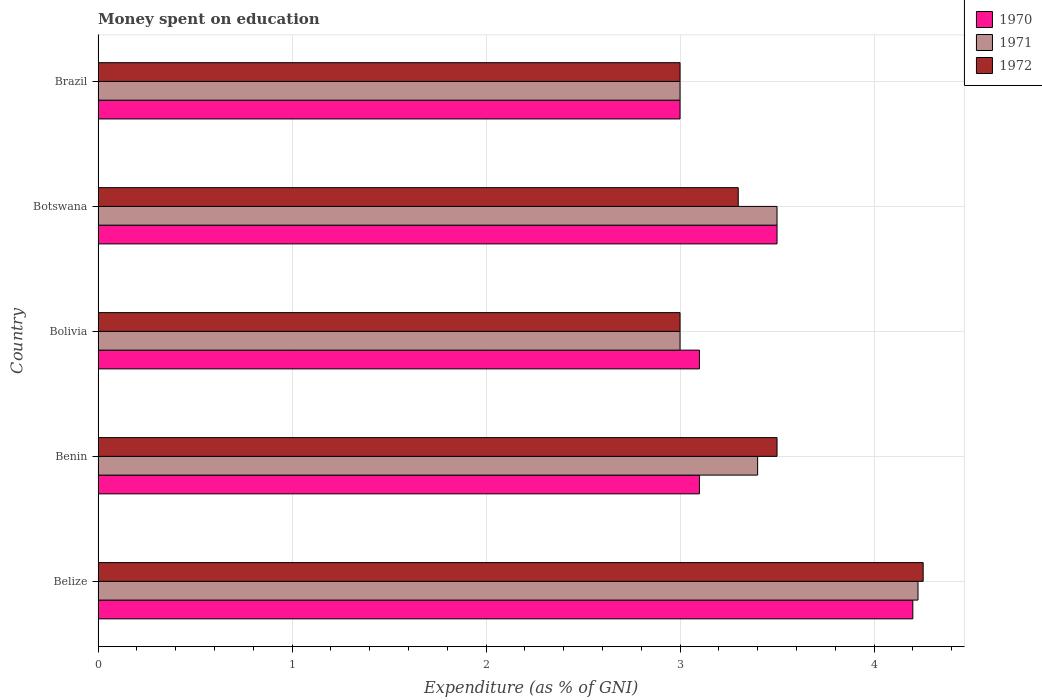How many different coloured bars are there?
Provide a short and direct response. 3. How many groups of bars are there?
Give a very brief answer. 5. Are the number of bars on each tick of the Y-axis equal?
Provide a short and direct response. Yes. How many bars are there on the 2nd tick from the bottom?
Make the answer very short. 3. What is the label of the 5th group of bars from the top?
Make the answer very short. Belize. What is the amount of money spent on education in 1971 in Belize?
Make the answer very short. 4.23. Across all countries, what is the maximum amount of money spent on education in 1971?
Provide a succinct answer. 4.23. Across all countries, what is the minimum amount of money spent on education in 1970?
Give a very brief answer. 3. In which country was the amount of money spent on education in 1970 maximum?
Provide a short and direct response. Belize. What is the total amount of money spent on education in 1971 in the graph?
Your response must be concise. 17.13. What is the difference between the amount of money spent on education in 1970 in Bolivia and that in Brazil?
Your answer should be very brief. 0.1. What is the difference between the amount of money spent on education in 1970 in Bolivia and the amount of money spent on education in 1971 in Belize?
Keep it short and to the point. -1.13. What is the average amount of money spent on education in 1970 per country?
Keep it short and to the point. 3.38. What is the ratio of the amount of money spent on education in 1972 in Benin to that in Bolivia?
Provide a succinct answer. 1.17. Is the difference between the amount of money spent on education in 1971 in Belize and Benin greater than the difference between the amount of money spent on education in 1972 in Belize and Benin?
Give a very brief answer. Yes. What is the difference between the highest and the second highest amount of money spent on education in 1972?
Make the answer very short. 0.75. What is the difference between the highest and the lowest amount of money spent on education in 1971?
Keep it short and to the point. 1.23. Is the sum of the amount of money spent on education in 1970 in Bolivia and Botswana greater than the maximum amount of money spent on education in 1972 across all countries?
Provide a short and direct response. Yes. Is it the case that in every country, the sum of the amount of money spent on education in 1971 and amount of money spent on education in 1970 is greater than the amount of money spent on education in 1972?
Make the answer very short. Yes. How many bars are there?
Offer a terse response. 15. What is the difference between two consecutive major ticks on the X-axis?
Your response must be concise. 1. How many legend labels are there?
Offer a very short reply. 3. How are the legend labels stacked?
Keep it short and to the point. Vertical. What is the title of the graph?
Your answer should be very brief. Money spent on education. Does "1968" appear as one of the legend labels in the graph?
Your answer should be very brief. No. What is the label or title of the X-axis?
Provide a succinct answer. Expenditure (as % of GNI). What is the Expenditure (as % of GNI) in 1970 in Belize?
Provide a succinct answer. 4.2. What is the Expenditure (as % of GNI) of 1971 in Belize?
Provide a succinct answer. 4.23. What is the Expenditure (as % of GNI) of 1972 in Belize?
Your answer should be very brief. 4.25. What is the Expenditure (as % of GNI) in 1970 in Benin?
Offer a very short reply. 3.1. What is the Expenditure (as % of GNI) in 1970 in Bolivia?
Offer a terse response. 3.1. What is the Expenditure (as % of GNI) of 1971 in Bolivia?
Your answer should be compact. 3. What is the Expenditure (as % of GNI) of 1972 in Bolivia?
Provide a short and direct response. 3. What is the Expenditure (as % of GNI) in 1971 in Botswana?
Offer a very short reply. 3.5. What is the Expenditure (as % of GNI) in 1972 in Botswana?
Offer a terse response. 3.3. What is the Expenditure (as % of GNI) in 1970 in Brazil?
Your answer should be very brief. 3. What is the Expenditure (as % of GNI) of 1971 in Brazil?
Provide a short and direct response. 3. What is the Expenditure (as % of GNI) in 1972 in Brazil?
Provide a succinct answer. 3. Across all countries, what is the maximum Expenditure (as % of GNI) in 1970?
Provide a succinct answer. 4.2. Across all countries, what is the maximum Expenditure (as % of GNI) in 1971?
Ensure brevity in your answer.  4.23. Across all countries, what is the maximum Expenditure (as % of GNI) in 1972?
Keep it short and to the point. 4.25. Across all countries, what is the minimum Expenditure (as % of GNI) of 1970?
Offer a terse response. 3. Across all countries, what is the minimum Expenditure (as % of GNI) in 1972?
Provide a succinct answer. 3. What is the total Expenditure (as % of GNI) in 1971 in the graph?
Keep it short and to the point. 17.13. What is the total Expenditure (as % of GNI) in 1972 in the graph?
Your answer should be very brief. 17.05. What is the difference between the Expenditure (as % of GNI) of 1970 in Belize and that in Benin?
Provide a succinct answer. 1.1. What is the difference between the Expenditure (as % of GNI) in 1971 in Belize and that in Benin?
Offer a very short reply. 0.83. What is the difference between the Expenditure (as % of GNI) in 1972 in Belize and that in Benin?
Your answer should be very brief. 0.75. What is the difference between the Expenditure (as % of GNI) of 1970 in Belize and that in Bolivia?
Offer a very short reply. 1.1. What is the difference between the Expenditure (as % of GNI) in 1971 in Belize and that in Bolivia?
Keep it short and to the point. 1.23. What is the difference between the Expenditure (as % of GNI) of 1972 in Belize and that in Bolivia?
Make the answer very short. 1.25. What is the difference between the Expenditure (as % of GNI) in 1970 in Belize and that in Botswana?
Ensure brevity in your answer.  0.7. What is the difference between the Expenditure (as % of GNI) in 1971 in Belize and that in Botswana?
Make the answer very short. 0.73. What is the difference between the Expenditure (as % of GNI) of 1972 in Belize and that in Botswana?
Provide a succinct answer. 0.95. What is the difference between the Expenditure (as % of GNI) of 1970 in Belize and that in Brazil?
Your answer should be compact. 1.2. What is the difference between the Expenditure (as % of GNI) of 1971 in Belize and that in Brazil?
Provide a succinct answer. 1.23. What is the difference between the Expenditure (as % of GNI) of 1972 in Belize and that in Brazil?
Your response must be concise. 1.25. What is the difference between the Expenditure (as % of GNI) of 1972 in Benin and that in Botswana?
Keep it short and to the point. 0.2. What is the difference between the Expenditure (as % of GNI) of 1970 in Benin and that in Brazil?
Offer a very short reply. 0.1. What is the difference between the Expenditure (as % of GNI) in 1971 in Benin and that in Brazil?
Provide a succinct answer. 0.4. What is the difference between the Expenditure (as % of GNI) of 1972 in Bolivia and that in Botswana?
Offer a terse response. -0.3. What is the difference between the Expenditure (as % of GNI) in 1970 in Botswana and that in Brazil?
Ensure brevity in your answer.  0.5. What is the difference between the Expenditure (as % of GNI) of 1970 in Belize and the Expenditure (as % of GNI) of 1971 in Benin?
Provide a succinct answer. 0.8. What is the difference between the Expenditure (as % of GNI) in 1971 in Belize and the Expenditure (as % of GNI) in 1972 in Benin?
Ensure brevity in your answer.  0.73. What is the difference between the Expenditure (as % of GNI) in 1970 in Belize and the Expenditure (as % of GNI) in 1972 in Bolivia?
Give a very brief answer. 1.2. What is the difference between the Expenditure (as % of GNI) of 1971 in Belize and the Expenditure (as % of GNI) of 1972 in Bolivia?
Your response must be concise. 1.23. What is the difference between the Expenditure (as % of GNI) in 1970 in Belize and the Expenditure (as % of GNI) in 1972 in Botswana?
Ensure brevity in your answer.  0.9. What is the difference between the Expenditure (as % of GNI) of 1971 in Belize and the Expenditure (as % of GNI) of 1972 in Botswana?
Provide a short and direct response. 0.93. What is the difference between the Expenditure (as % of GNI) in 1971 in Belize and the Expenditure (as % of GNI) in 1972 in Brazil?
Provide a short and direct response. 1.23. What is the difference between the Expenditure (as % of GNI) of 1970 in Benin and the Expenditure (as % of GNI) of 1971 in Bolivia?
Give a very brief answer. 0.1. What is the difference between the Expenditure (as % of GNI) in 1970 in Benin and the Expenditure (as % of GNI) in 1972 in Bolivia?
Your answer should be compact. 0.1. What is the difference between the Expenditure (as % of GNI) of 1971 in Benin and the Expenditure (as % of GNI) of 1972 in Bolivia?
Your answer should be compact. 0.4. What is the difference between the Expenditure (as % of GNI) of 1970 in Benin and the Expenditure (as % of GNI) of 1972 in Botswana?
Make the answer very short. -0.2. What is the difference between the Expenditure (as % of GNI) in 1970 in Benin and the Expenditure (as % of GNI) in 1971 in Brazil?
Keep it short and to the point. 0.1. What is the difference between the Expenditure (as % of GNI) of 1970 in Benin and the Expenditure (as % of GNI) of 1972 in Brazil?
Offer a terse response. 0.1. What is the difference between the Expenditure (as % of GNI) in 1970 in Bolivia and the Expenditure (as % of GNI) in 1971 in Botswana?
Your response must be concise. -0.4. What is the difference between the Expenditure (as % of GNI) in 1971 in Bolivia and the Expenditure (as % of GNI) in 1972 in Botswana?
Your answer should be very brief. -0.3. What is the difference between the Expenditure (as % of GNI) of 1971 in Bolivia and the Expenditure (as % of GNI) of 1972 in Brazil?
Give a very brief answer. 0. What is the difference between the Expenditure (as % of GNI) of 1971 in Botswana and the Expenditure (as % of GNI) of 1972 in Brazil?
Keep it short and to the point. 0.5. What is the average Expenditure (as % of GNI) of 1970 per country?
Your response must be concise. 3.38. What is the average Expenditure (as % of GNI) of 1971 per country?
Give a very brief answer. 3.43. What is the average Expenditure (as % of GNI) of 1972 per country?
Your answer should be compact. 3.41. What is the difference between the Expenditure (as % of GNI) in 1970 and Expenditure (as % of GNI) in 1971 in Belize?
Your response must be concise. -0.03. What is the difference between the Expenditure (as % of GNI) of 1970 and Expenditure (as % of GNI) of 1972 in Belize?
Give a very brief answer. -0.05. What is the difference between the Expenditure (as % of GNI) of 1971 and Expenditure (as % of GNI) of 1972 in Belize?
Keep it short and to the point. -0.03. What is the difference between the Expenditure (as % of GNI) in 1970 and Expenditure (as % of GNI) in 1971 in Benin?
Offer a very short reply. -0.3. What is the difference between the Expenditure (as % of GNI) of 1971 and Expenditure (as % of GNI) of 1972 in Benin?
Provide a short and direct response. -0.1. What is the difference between the Expenditure (as % of GNI) of 1970 and Expenditure (as % of GNI) of 1971 in Bolivia?
Your response must be concise. 0.1. What is the difference between the Expenditure (as % of GNI) of 1971 and Expenditure (as % of GNI) of 1972 in Bolivia?
Offer a very short reply. 0. What is the difference between the Expenditure (as % of GNI) in 1970 and Expenditure (as % of GNI) in 1972 in Botswana?
Make the answer very short. 0.2. What is the difference between the Expenditure (as % of GNI) in 1971 and Expenditure (as % of GNI) in 1972 in Brazil?
Make the answer very short. 0. What is the ratio of the Expenditure (as % of GNI) in 1970 in Belize to that in Benin?
Your answer should be very brief. 1.35. What is the ratio of the Expenditure (as % of GNI) of 1971 in Belize to that in Benin?
Keep it short and to the point. 1.24. What is the ratio of the Expenditure (as % of GNI) of 1972 in Belize to that in Benin?
Your response must be concise. 1.22. What is the ratio of the Expenditure (as % of GNI) in 1970 in Belize to that in Bolivia?
Provide a short and direct response. 1.35. What is the ratio of the Expenditure (as % of GNI) in 1971 in Belize to that in Bolivia?
Keep it short and to the point. 1.41. What is the ratio of the Expenditure (as % of GNI) of 1972 in Belize to that in Bolivia?
Provide a succinct answer. 1.42. What is the ratio of the Expenditure (as % of GNI) of 1970 in Belize to that in Botswana?
Provide a succinct answer. 1.2. What is the ratio of the Expenditure (as % of GNI) in 1971 in Belize to that in Botswana?
Your answer should be compact. 1.21. What is the ratio of the Expenditure (as % of GNI) of 1972 in Belize to that in Botswana?
Your answer should be compact. 1.29. What is the ratio of the Expenditure (as % of GNI) of 1971 in Belize to that in Brazil?
Provide a short and direct response. 1.41. What is the ratio of the Expenditure (as % of GNI) of 1972 in Belize to that in Brazil?
Make the answer very short. 1.42. What is the ratio of the Expenditure (as % of GNI) of 1971 in Benin to that in Bolivia?
Keep it short and to the point. 1.13. What is the ratio of the Expenditure (as % of GNI) of 1970 in Benin to that in Botswana?
Make the answer very short. 0.89. What is the ratio of the Expenditure (as % of GNI) in 1971 in Benin to that in Botswana?
Make the answer very short. 0.97. What is the ratio of the Expenditure (as % of GNI) of 1972 in Benin to that in Botswana?
Give a very brief answer. 1.06. What is the ratio of the Expenditure (as % of GNI) in 1970 in Benin to that in Brazil?
Offer a very short reply. 1.03. What is the ratio of the Expenditure (as % of GNI) of 1971 in Benin to that in Brazil?
Give a very brief answer. 1.13. What is the ratio of the Expenditure (as % of GNI) in 1970 in Bolivia to that in Botswana?
Keep it short and to the point. 0.89. What is the ratio of the Expenditure (as % of GNI) of 1971 in Bolivia to that in Botswana?
Make the answer very short. 0.86. What is the ratio of the Expenditure (as % of GNI) of 1972 in Bolivia to that in Botswana?
Make the answer very short. 0.91. What is the ratio of the Expenditure (as % of GNI) in 1971 in Bolivia to that in Brazil?
Provide a succinct answer. 1. What is the ratio of the Expenditure (as % of GNI) of 1971 in Botswana to that in Brazil?
Your response must be concise. 1.17. What is the ratio of the Expenditure (as % of GNI) in 1972 in Botswana to that in Brazil?
Offer a terse response. 1.1. What is the difference between the highest and the second highest Expenditure (as % of GNI) of 1970?
Your response must be concise. 0.7. What is the difference between the highest and the second highest Expenditure (as % of GNI) in 1971?
Your answer should be compact. 0.73. What is the difference between the highest and the second highest Expenditure (as % of GNI) in 1972?
Give a very brief answer. 0.75. What is the difference between the highest and the lowest Expenditure (as % of GNI) in 1971?
Keep it short and to the point. 1.23. What is the difference between the highest and the lowest Expenditure (as % of GNI) of 1972?
Provide a succinct answer. 1.25. 